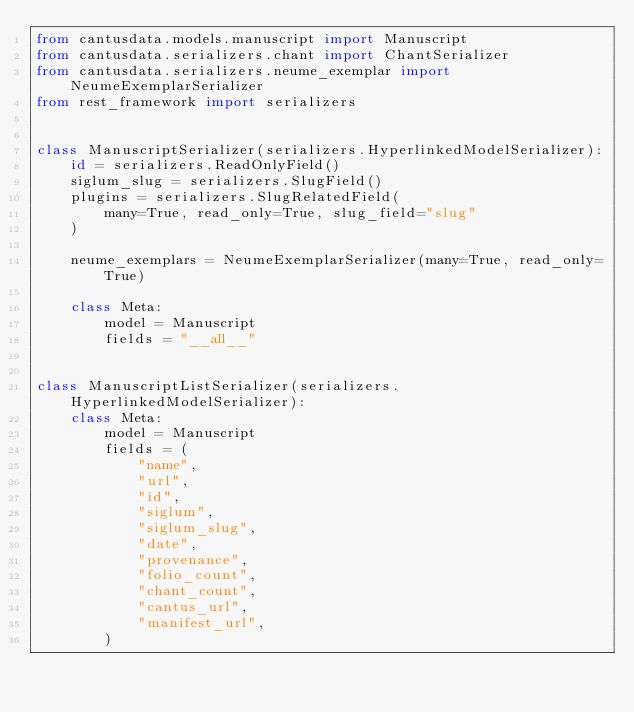Convert code to text. <code><loc_0><loc_0><loc_500><loc_500><_Python_>from cantusdata.models.manuscript import Manuscript
from cantusdata.serializers.chant import ChantSerializer
from cantusdata.serializers.neume_exemplar import NeumeExemplarSerializer
from rest_framework import serializers


class ManuscriptSerializer(serializers.HyperlinkedModelSerializer):
    id = serializers.ReadOnlyField()
    siglum_slug = serializers.SlugField()
    plugins = serializers.SlugRelatedField(
        many=True, read_only=True, slug_field="slug"
    )

    neume_exemplars = NeumeExemplarSerializer(many=True, read_only=True)

    class Meta:
        model = Manuscript
        fields = "__all__"


class ManuscriptListSerializer(serializers.HyperlinkedModelSerializer):
    class Meta:
        model = Manuscript
        fields = (
            "name",
            "url",
            "id",
            "siglum",
            "siglum_slug",
            "date",
            "provenance",
            "folio_count",
            "chant_count",
            "cantus_url",
            "manifest_url",
        )
</code> 